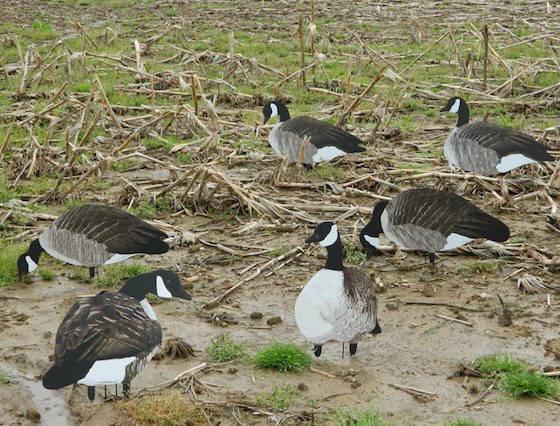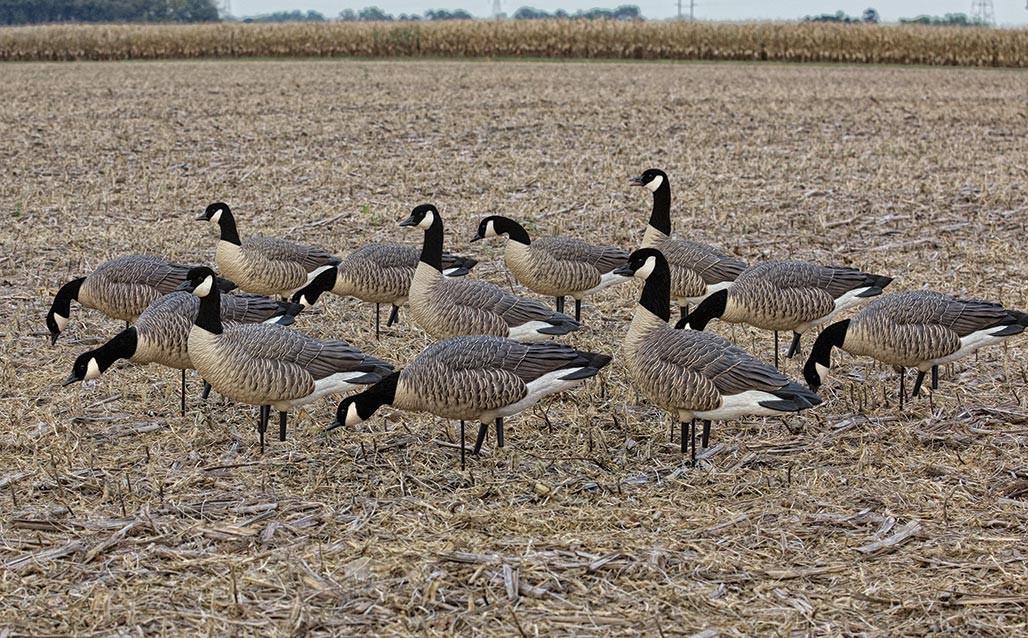The first image is the image on the left, the second image is the image on the right. Assess this claim about the two images: "There are at least two ducks standing next to each other with orange beaks.". Correct or not? Answer yes or no. No. The first image is the image on the left, the second image is the image on the right. Assess this claim about the two images: "Each image shows a flock of canada geese with no fewer than 6 birds". Correct or not? Answer yes or no. Yes. The first image is the image on the left, the second image is the image on the right. For the images displayed, is the sentence "At least one person is walking with the birds in one of the images." factually correct? Answer yes or no. No. The first image is the image on the left, the second image is the image on the right. Analyze the images presented: Is the assertion "An image shows a girl in a head covering standing behind a flock of white birds and holding a stick." valid? Answer yes or no. No. 